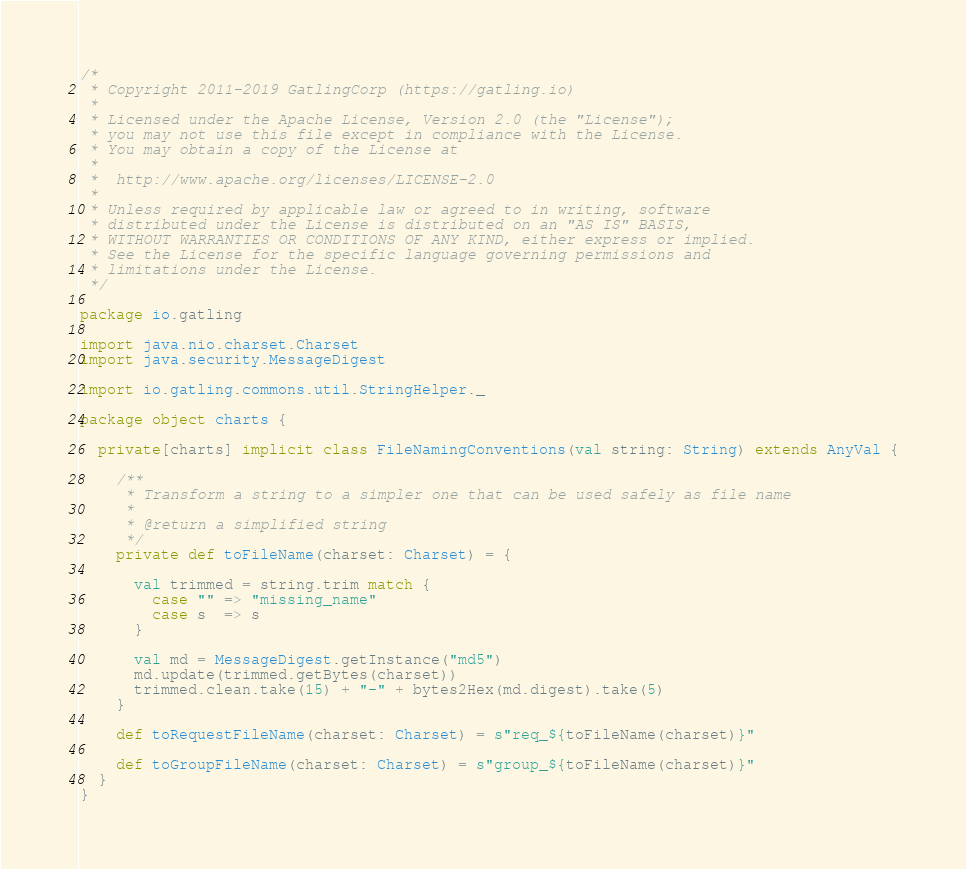<code> <loc_0><loc_0><loc_500><loc_500><_Scala_>/*
 * Copyright 2011-2019 GatlingCorp (https://gatling.io)
 *
 * Licensed under the Apache License, Version 2.0 (the "License");
 * you may not use this file except in compliance with the License.
 * You may obtain a copy of the License at
 *
 *  http://www.apache.org/licenses/LICENSE-2.0
 *
 * Unless required by applicable law or agreed to in writing, software
 * distributed under the License is distributed on an "AS IS" BASIS,
 * WITHOUT WARRANTIES OR CONDITIONS OF ANY KIND, either express or implied.
 * See the License for the specific language governing permissions and
 * limitations under the License.
 */

package io.gatling

import java.nio.charset.Charset
import java.security.MessageDigest

import io.gatling.commons.util.StringHelper._

package object charts {

  private[charts] implicit class FileNamingConventions(val string: String) extends AnyVal {

    /**
     * Transform a string to a simpler one that can be used safely as file name
     *
     * @return a simplified string
     */
    private def toFileName(charset: Charset) = {

      val trimmed = string.trim match {
        case "" => "missing_name"
        case s  => s
      }

      val md = MessageDigest.getInstance("md5")
      md.update(trimmed.getBytes(charset))
      trimmed.clean.take(15) + "-" + bytes2Hex(md.digest).take(5)
    }

    def toRequestFileName(charset: Charset) = s"req_${toFileName(charset)}"

    def toGroupFileName(charset: Charset) = s"group_${toFileName(charset)}"
  }
}
</code> 